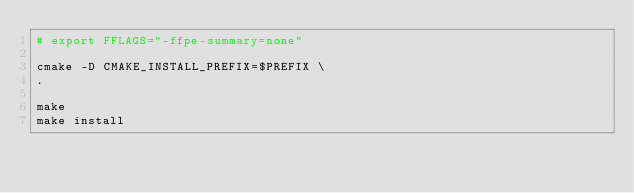<code> <loc_0><loc_0><loc_500><loc_500><_Bash_># export FFLAGS="-ffpe-summary=none"

cmake -D CMAKE_INSTALL_PREFIX=$PREFIX \
.

make
make install
</code> 